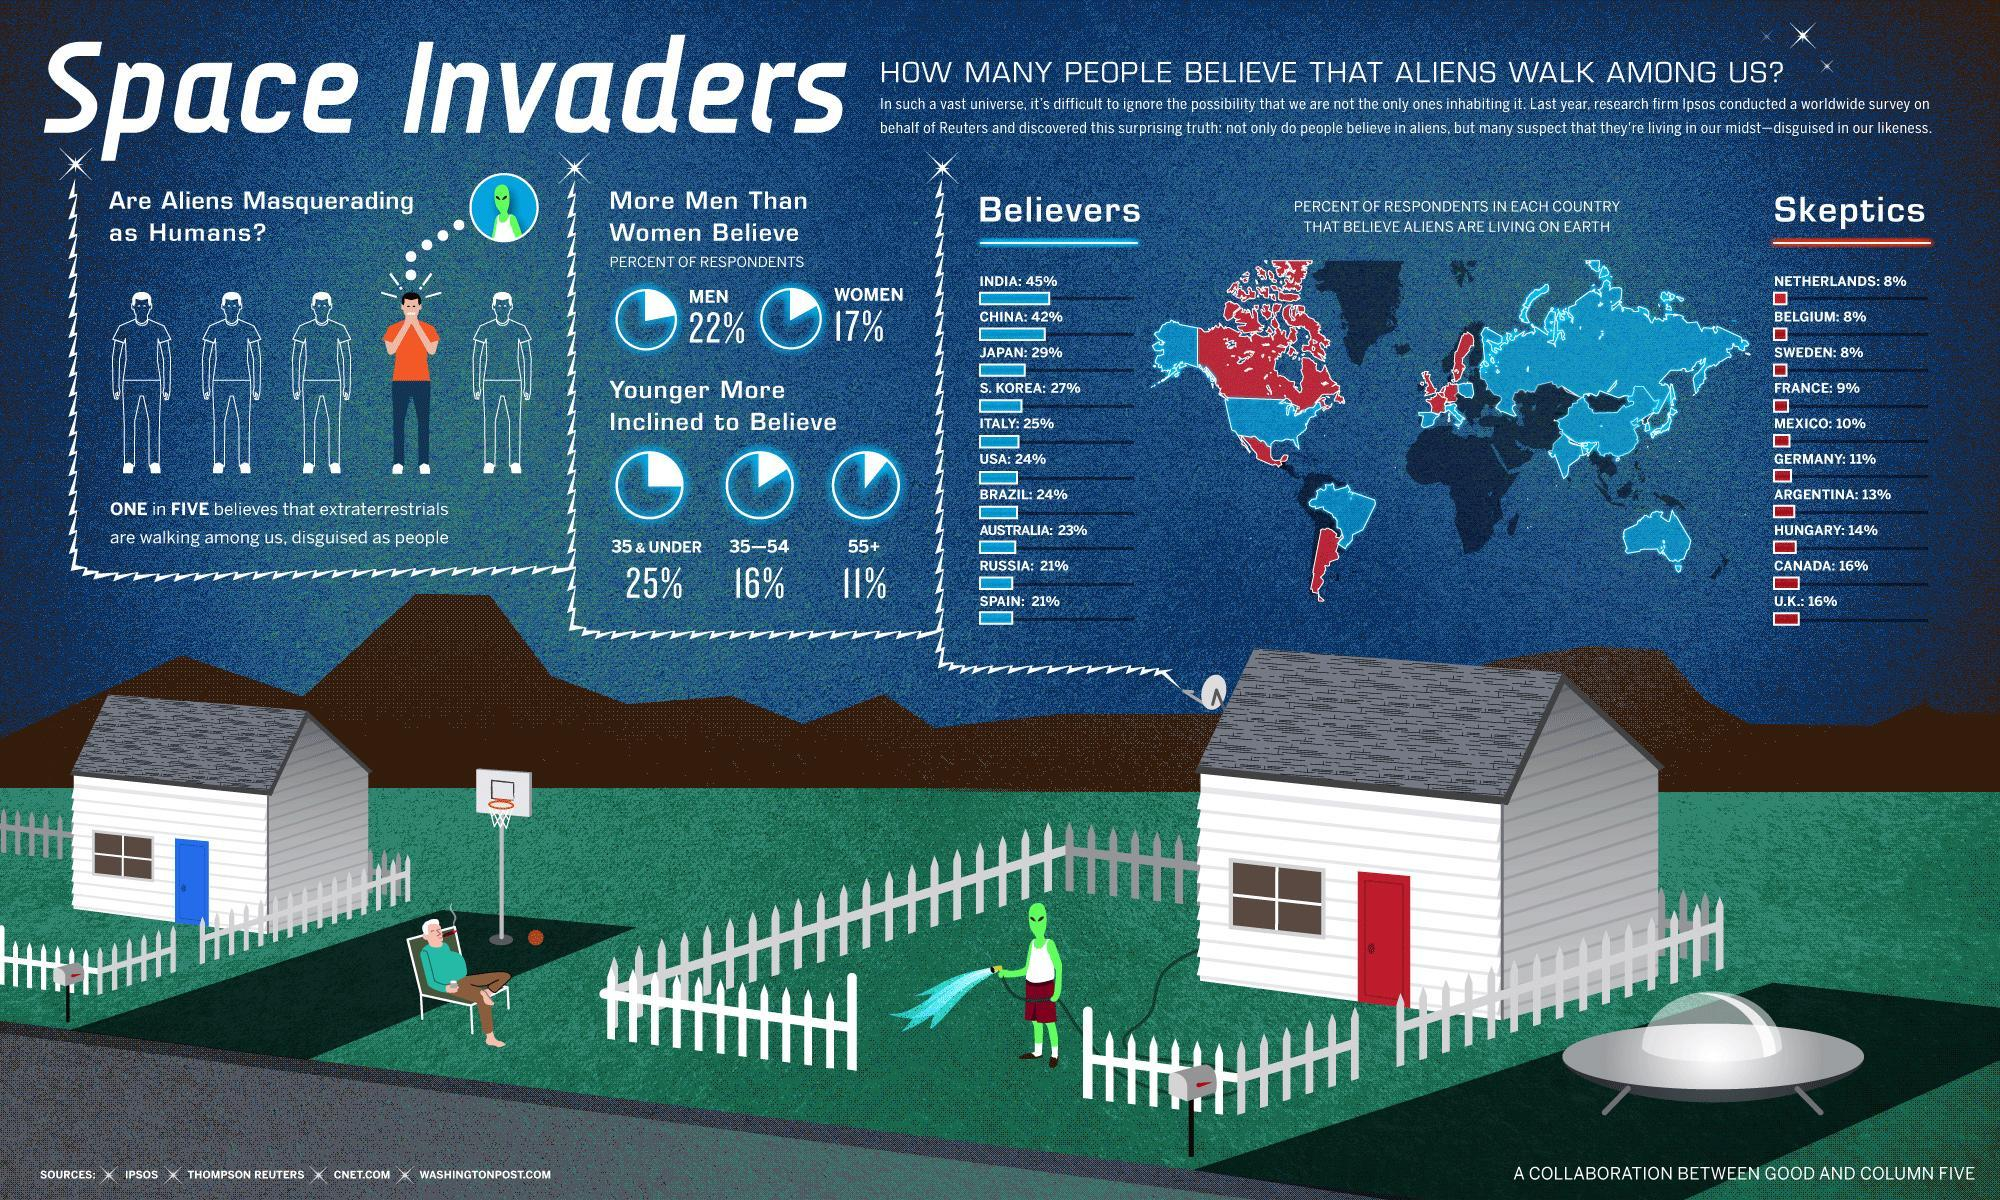Which of the two categories are more in percentile numbers, Believers or Non-believers of aliens?
Answer the question with a short phrase. Believers What is percentage of people below 35 years believe in extraterrestrials, 11%, 16%, or 25%? 11% What is the percentage of skeptics from the continent of South America? 10% Which countries have the highest number of skeptics? Canada, UK Which countries have the least number of believers? Russia, Spain What is the percentage of women who believe in space invaders, 22%, 17%, or 45%? 17% 